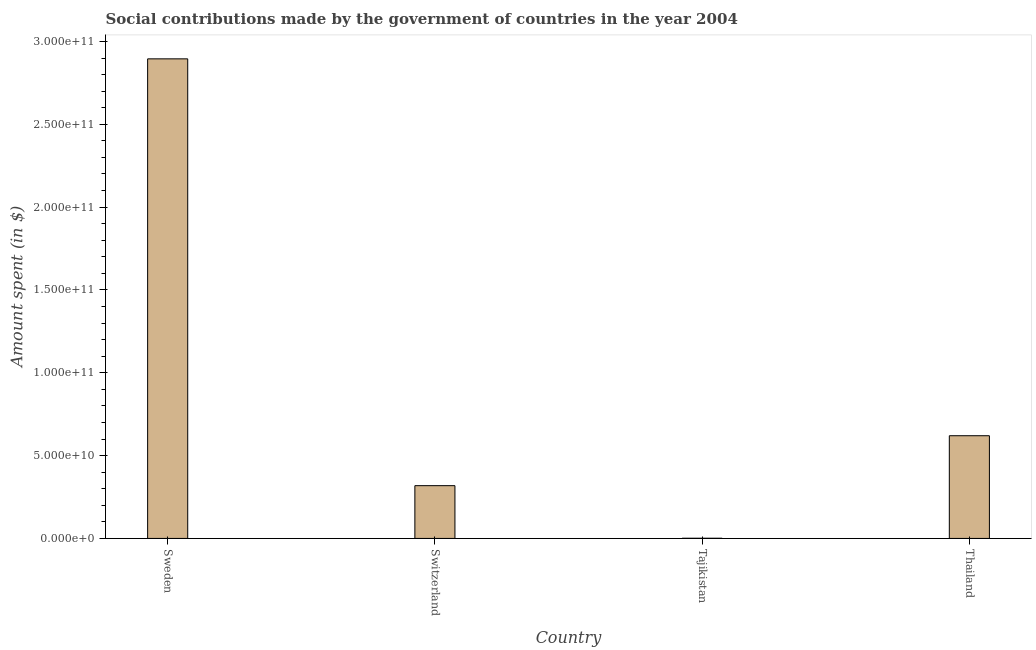What is the title of the graph?
Provide a succinct answer. Social contributions made by the government of countries in the year 2004. What is the label or title of the Y-axis?
Make the answer very short. Amount spent (in $). What is the amount spent in making social contributions in Switzerland?
Ensure brevity in your answer.  3.19e+1. Across all countries, what is the maximum amount spent in making social contributions?
Ensure brevity in your answer.  2.89e+11. Across all countries, what is the minimum amount spent in making social contributions?
Keep it short and to the point. 1.09e+08. In which country was the amount spent in making social contributions maximum?
Give a very brief answer. Sweden. In which country was the amount spent in making social contributions minimum?
Offer a very short reply. Tajikistan. What is the sum of the amount spent in making social contributions?
Your answer should be very brief. 3.83e+11. What is the difference between the amount spent in making social contributions in Tajikistan and Thailand?
Your response must be concise. -6.19e+1. What is the average amount spent in making social contributions per country?
Make the answer very short. 9.59e+1. What is the median amount spent in making social contributions?
Your response must be concise. 4.69e+1. What is the ratio of the amount spent in making social contributions in Sweden to that in Tajikistan?
Ensure brevity in your answer.  2665.17. Is the amount spent in making social contributions in Switzerland less than that in Thailand?
Keep it short and to the point. Yes. Is the difference between the amount spent in making social contributions in Switzerland and Thailand greater than the difference between any two countries?
Provide a succinct answer. No. What is the difference between the highest and the second highest amount spent in making social contributions?
Offer a terse response. 2.27e+11. Is the sum of the amount spent in making social contributions in Tajikistan and Thailand greater than the maximum amount spent in making social contributions across all countries?
Make the answer very short. No. What is the difference between the highest and the lowest amount spent in making social contributions?
Give a very brief answer. 2.89e+11. In how many countries, is the amount spent in making social contributions greater than the average amount spent in making social contributions taken over all countries?
Make the answer very short. 1. How many bars are there?
Your answer should be very brief. 4. How many countries are there in the graph?
Make the answer very short. 4. What is the Amount spent (in $) of Sweden?
Offer a very short reply. 2.89e+11. What is the Amount spent (in $) in Switzerland?
Ensure brevity in your answer.  3.19e+1. What is the Amount spent (in $) in Tajikistan?
Keep it short and to the point. 1.09e+08. What is the Amount spent (in $) in Thailand?
Provide a short and direct response. 6.20e+1. What is the difference between the Amount spent (in $) in Sweden and Switzerland?
Make the answer very short. 2.58e+11. What is the difference between the Amount spent (in $) in Sweden and Tajikistan?
Provide a succinct answer. 2.89e+11. What is the difference between the Amount spent (in $) in Sweden and Thailand?
Ensure brevity in your answer.  2.27e+11. What is the difference between the Amount spent (in $) in Switzerland and Tajikistan?
Give a very brief answer. 3.17e+1. What is the difference between the Amount spent (in $) in Switzerland and Thailand?
Your answer should be very brief. -3.01e+1. What is the difference between the Amount spent (in $) in Tajikistan and Thailand?
Make the answer very short. -6.19e+1. What is the ratio of the Amount spent (in $) in Sweden to that in Switzerland?
Keep it short and to the point. 9.09. What is the ratio of the Amount spent (in $) in Sweden to that in Tajikistan?
Your response must be concise. 2665.17. What is the ratio of the Amount spent (in $) in Sweden to that in Thailand?
Offer a very short reply. 4.67. What is the ratio of the Amount spent (in $) in Switzerland to that in Tajikistan?
Your response must be concise. 293.25. What is the ratio of the Amount spent (in $) in Switzerland to that in Thailand?
Your answer should be compact. 0.51. What is the ratio of the Amount spent (in $) in Tajikistan to that in Thailand?
Give a very brief answer. 0. 